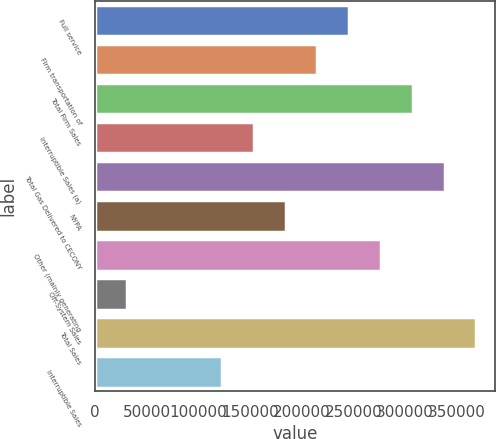Convert chart. <chart><loc_0><loc_0><loc_500><loc_500><bar_chart><fcel>Full service<fcel>Firm transportation of<fcel>Total Firm Sales<fcel>Interruptible Sales (a)<fcel>Total Gas Delivered to CECONY<fcel>NYPA<fcel>Other (mainly generating<fcel>Off-System Sales<fcel>Total Sales<fcel>Interruptible Sales<nl><fcel>245950<fcel>215208<fcel>307434<fcel>153723<fcel>338176<fcel>184465<fcel>276692<fcel>30754.5<fcel>368918<fcel>122981<nl></chart> 